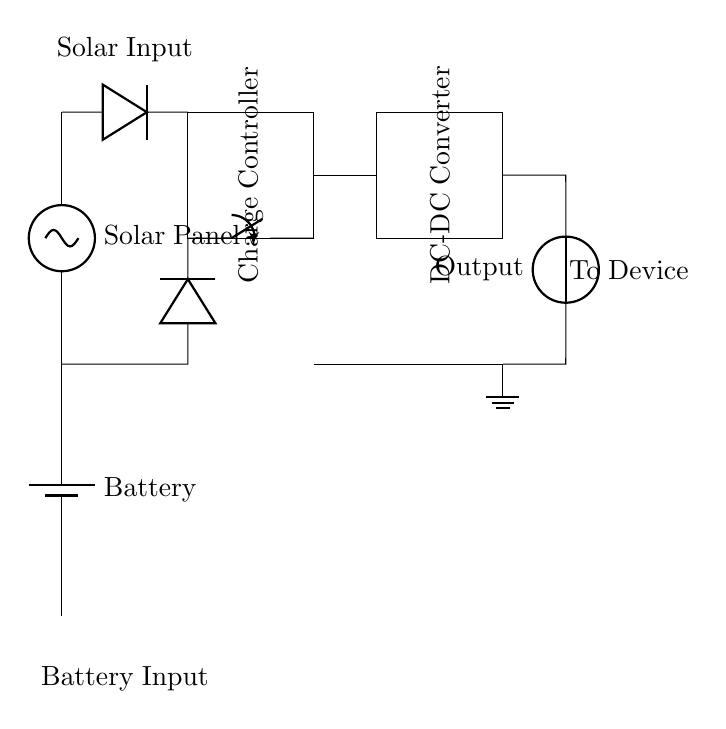What are the two power sources in this circuit? The circuit features a solar panel and a battery as its power sources, as indicated at the top and bottom of the diagram respectively.
Answer: solar panel, battery What function does the charge controller serve? The charge controller manages the power flow from the solar panel and battery to ensure proper charging and discharging, which is illustrated by its placement between the inputs and the DC-DC converter.
Answer: manages power flow What happens when the switch is open? If the switch is open, the circuit path from the battery to the charge controller is interrupted, preventing current from flowing from the battery, thus only allowing power from the solar panel to be used.
Answer: no battery power What is the output type of this circuit? The output is labeled as a voltage source, indicating that the circuit provides a stable voltage output to power a device.
Answer: voltage source How does the diode protect the circuit? The diodes prevent reverse current flow, ensuring that power from the solar panel or battery does not flow back into these sources, protecting them from potential damage.
Answer: prevents reverse current What does the DC-DC converter do in this setup? The DC-DC converter steps the voltage up or down as necessary to provide the required output voltage for the connected device, playing a critical role in power regulation.
Answer: regulates output voltage What indicates that solar power has priority over battery power? The arrangement in the circuit suggests that the solar panel connects directly to the charge controller with a diode first, indicating solar power is utilized first when available before using battery power.
Answer: solar power priority 